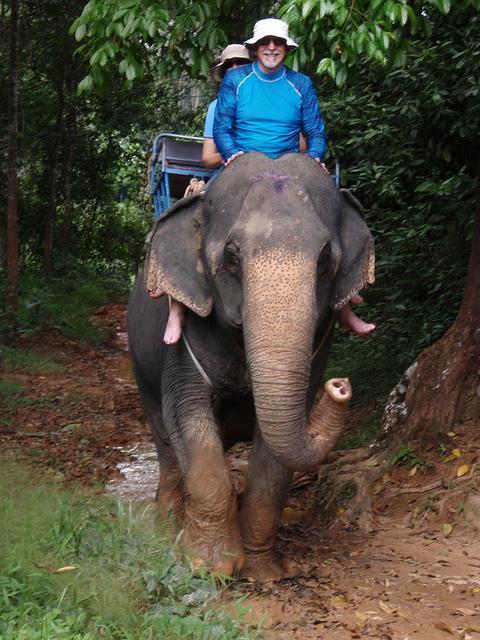How many people are on the animal?
Give a very brief answer. 2. How many people are visible?
Give a very brief answer. 2. 